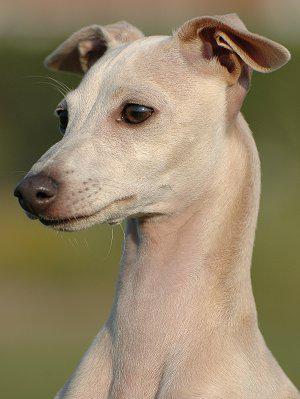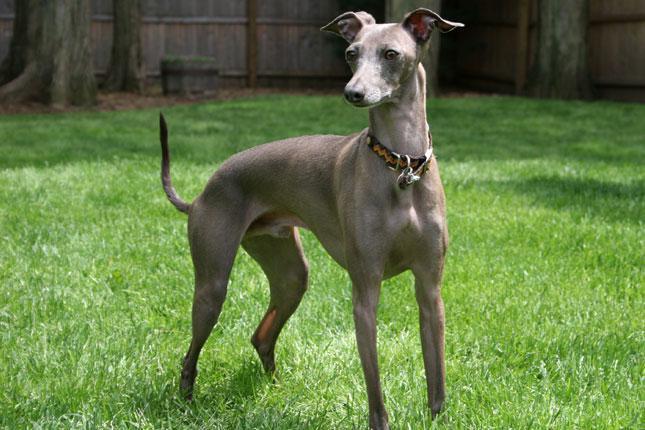The first image is the image on the left, the second image is the image on the right. Examine the images to the left and right. Is the description "The dog in the right image wears a collar." accurate? Answer yes or no. Yes. 